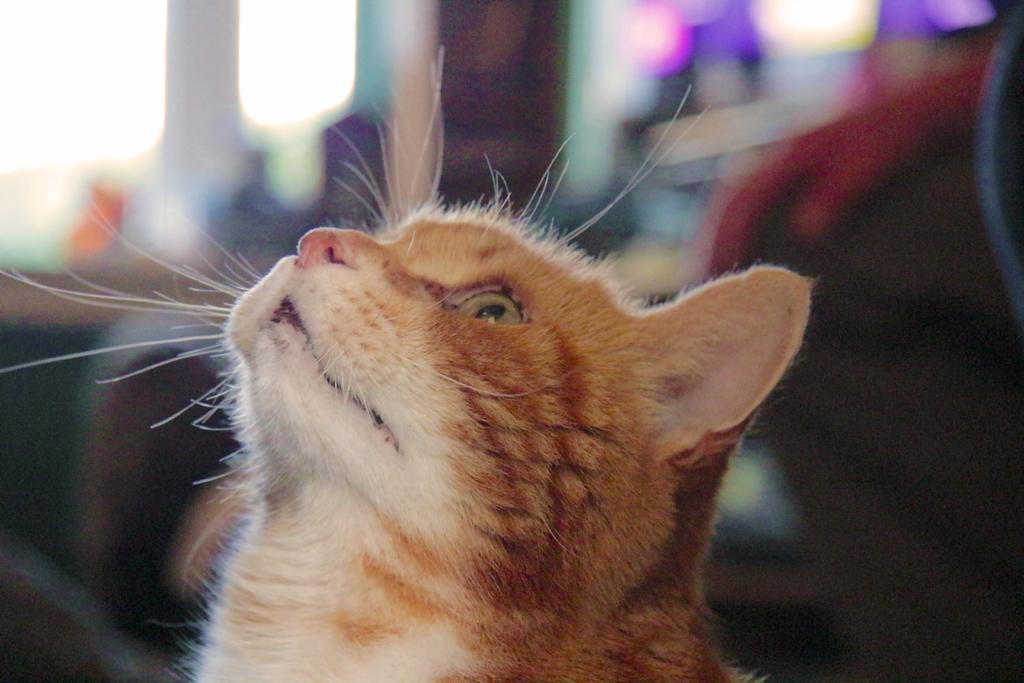Can you describe this image briefly? In this image we can see a cat. 